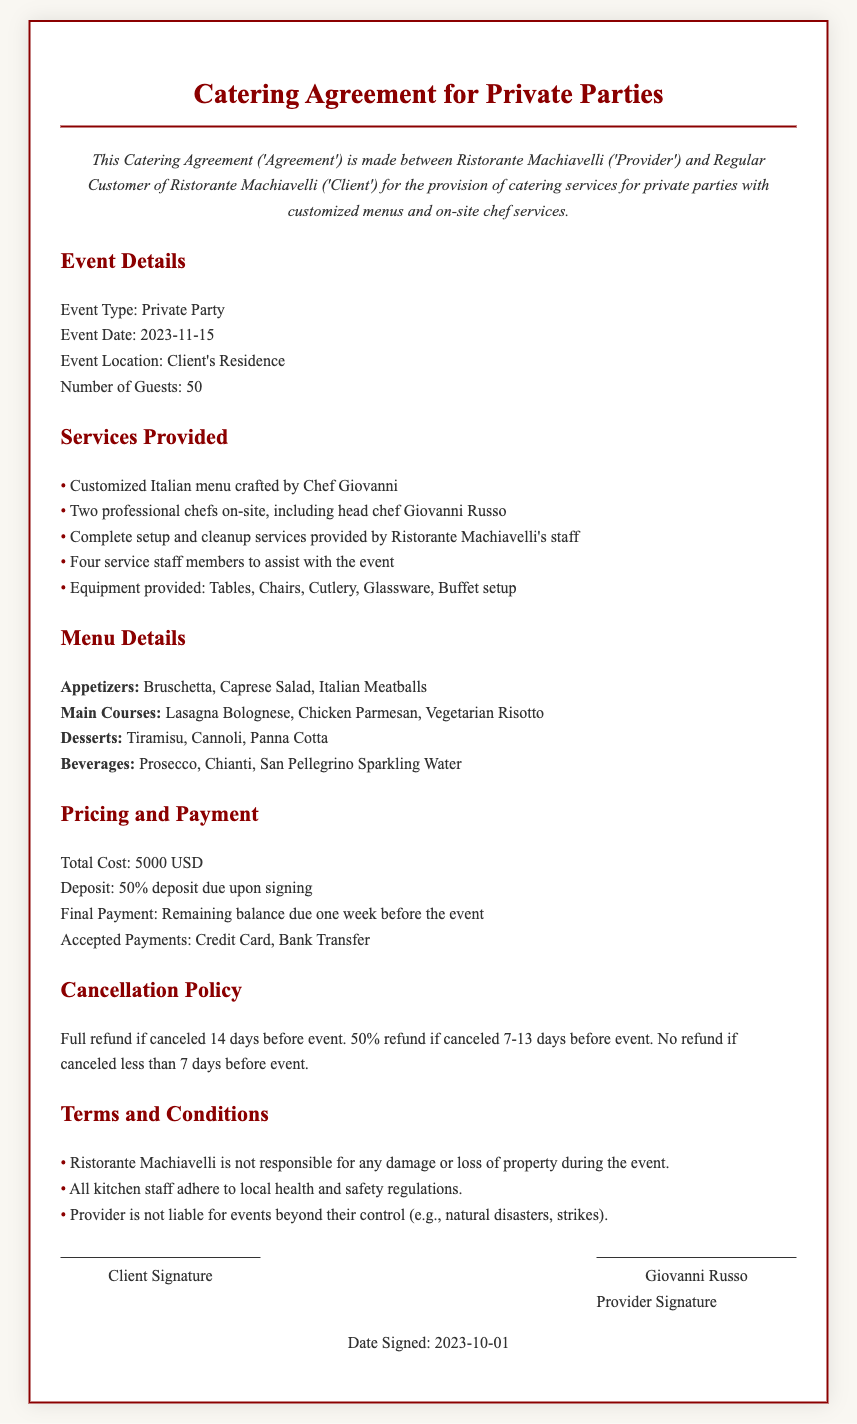what is the event date? The event date is specified in the document under Event Details as November 15, 2023.
Answer: November 15, 2023 who is the head chef? The head chef is identified in the document as Chef Giovanni Russo.
Answer: Chef Giovanni Russo how many guests are expected? The document states that there will be 50 guests for the private party.
Answer: 50 what is the total cost of the catering? The total cost is given in the Pricing and Payment section of the document as 5000 USD.
Answer: 5000 USD how much deposit is due upon signing? The document specifies that a 50% deposit is due upon signing the agreement.
Answer: 50% what is the cancellation policy for a cancellation less than 7 days before the event? In the Cancellation Policy section, it states that there is no refund if canceled less than 7 days before the event.
Answer: No refund what type of beverages are included in the menu? The menu details include Prosecco, Chianti, and San Pellegrino Sparkling Water as the beverages offered.
Answer: Prosecco, Chianti, San Pellegrino Sparkling Water what are the liabilities mentioned for the Provider? The document states that the Provider is not liable for events beyond their control, such as natural disasters or strikes.
Answer: Events beyond control how many service staff members are provided for the event? The document lists four service staff members to assist with the event setup and management.
Answer: Four service staff members 